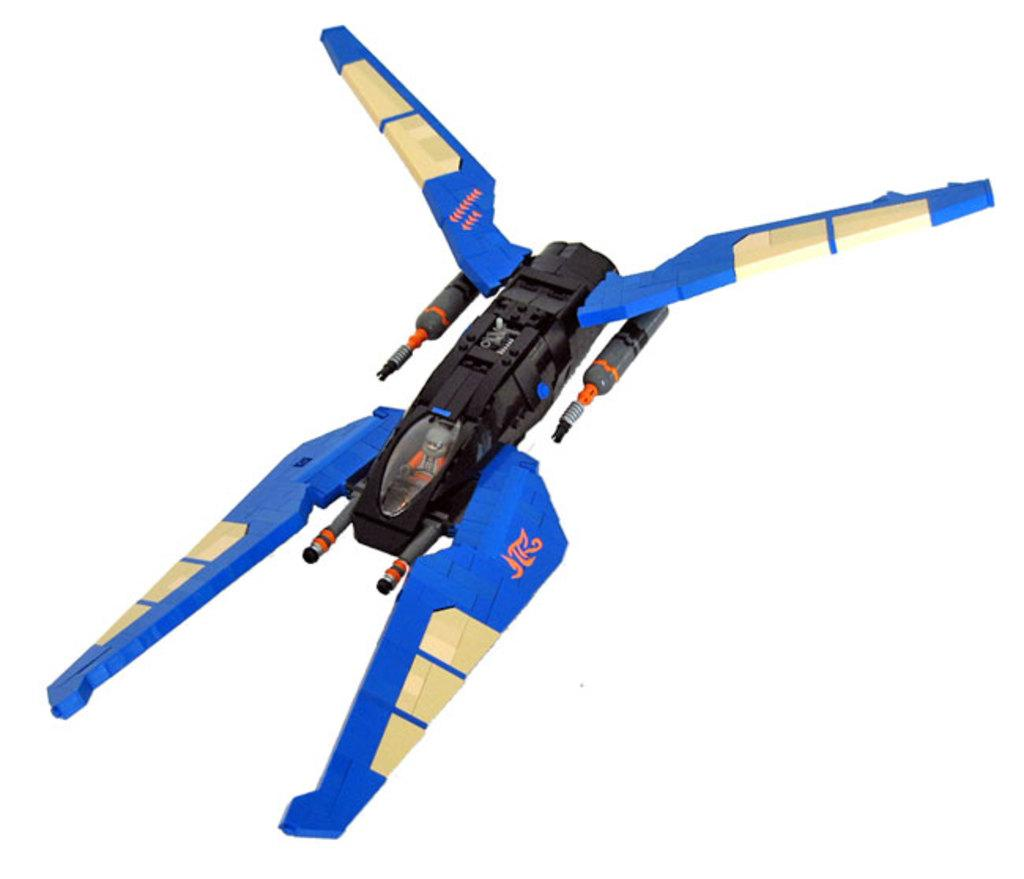What object can be seen in the image? There is a toy in the image. What color is the background of the image? The background of the image is white in color. What type of error can be seen in the image? There is no error present in the image; it features a toy against a white background. What type of tank is visible in the image? There is no tank present in the image. 